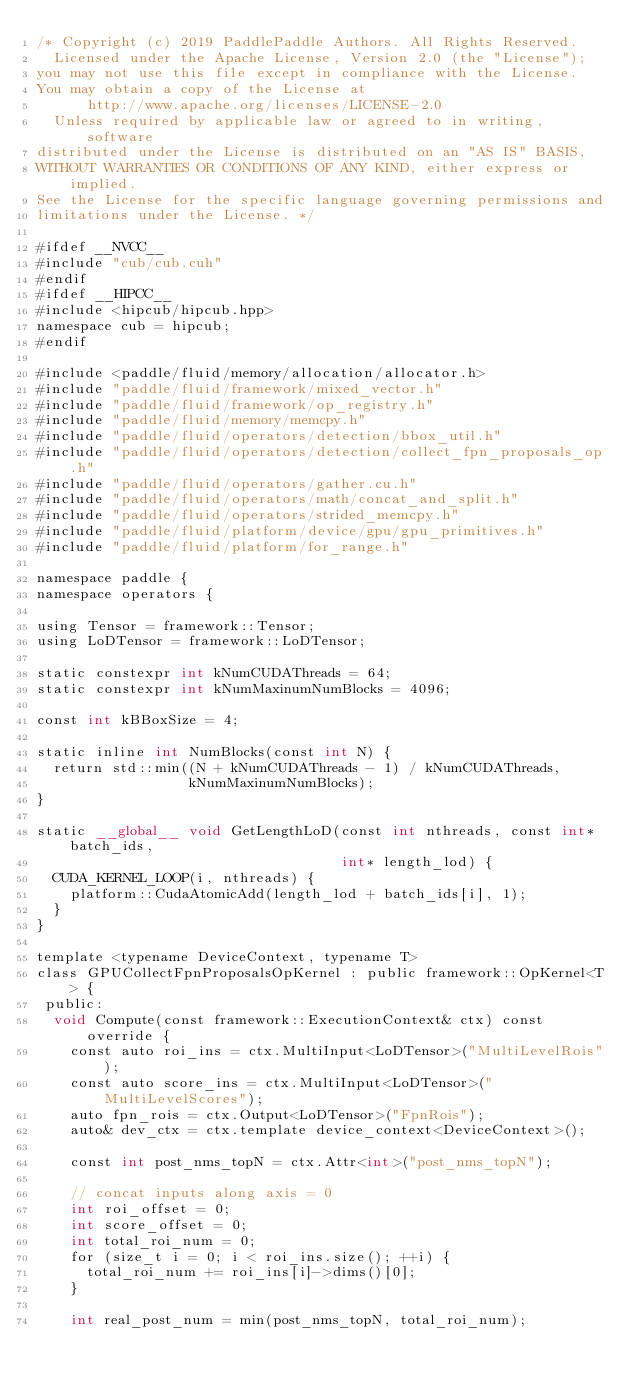Convert code to text. <code><loc_0><loc_0><loc_500><loc_500><_Cuda_>/* Copyright (c) 2019 PaddlePaddle Authors. All Rights Reserved.
  Licensed under the Apache License, Version 2.0 (the "License");
you may not use this file except in compliance with the License.
You may obtain a copy of the License at
      http://www.apache.org/licenses/LICENSE-2.0
  Unless required by applicable law or agreed to in writing, software
distributed under the License is distributed on an "AS IS" BASIS,
WITHOUT WARRANTIES OR CONDITIONS OF ANY KIND, either express or implied.
See the License for the specific language governing permissions and
limitations under the License. */

#ifdef __NVCC__
#include "cub/cub.cuh"
#endif
#ifdef __HIPCC__
#include <hipcub/hipcub.hpp>
namespace cub = hipcub;
#endif

#include <paddle/fluid/memory/allocation/allocator.h>
#include "paddle/fluid/framework/mixed_vector.h"
#include "paddle/fluid/framework/op_registry.h"
#include "paddle/fluid/memory/memcpy.h"
#include "paddle/fluid/operators/detection/bbox_util.h"
#include "paddle/fluid/operators/detection/collect_fpn_proposals_op.h"
#include "paddle/fluid/operators/gather.cu.h"
#include "paddle/fluid/operators/math/concat_and_split.h"
#include "paddle/fluid/operators/strided_memcpy.h"
#include "paddle/fluid/platform/device/gpu/gpu_primitives.h"
#include "paddle/fluid/platform/for_range.h"

namespace paddle {
namespace operators {

using Tensor = framework::Tensor;
using LoDTensor = framework::LoDTensor;

static constexpr int kNumCUDAThreads = 64;
static constexpr int kNumMaxinumNumBlocks = 4096;

const int kBBoxSize = 4;

static inline int NumBlocks(const int N) {
  return std::min((N + kNumCUDAThreads - 1) / kNumCUDAThreads,
                  kNumMaxinumNumBlocks);
}

static __global__ void GetLengthLoD(const int nthreads, const int* batch_ids,
                                    int* length_lod) {
  CUDA_KERNEL_LOOP(i, nthreads) {
    platform::CudaAtomicAdd(length_lod + batch_ids[i], 1);
  }
}

template <typename DeviceContext, typename T>
class GPUCollectFpnProposalsOpKernel : public framework::OpKernel<T> {
 public:
  void Compute(const framework::ExecutionContext& ctx) const override {
    const auto roi_ins = ctx.MultiInput<LoDTensor>("MultiLevelRois");
    const auto score_ins = ctx.MultiInput<LoDTensor>("MultiLevelScores");
    auto fpn_rois = ctx.Output<LoDTensor>("FpnRois");
    auto& dev_ctx = ctx.template device_context<DeviceContext>();

    const int post_nms_topN = ctx.Attr<int>("post_nms_topN");

    // concat inputs along axis = 0
    int roi_offset = 0;
    int score_offset = 0;
    int total_roi_num = 0;
    for (size_t i = 0; i < roi_ins.size(); ++i) {
      total_roi_num += roi_ins[i]->dims()[0];
    }

    int real_post_num = min(post_nms_topN, total_roi_num);</code> 